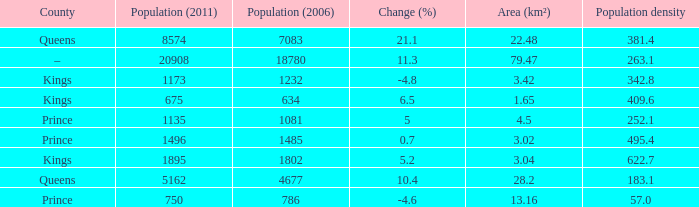What is the Population density that has a Change (%) higher than 10.4, and a Population (2011) less than 8574, in the County of Queens? None. 